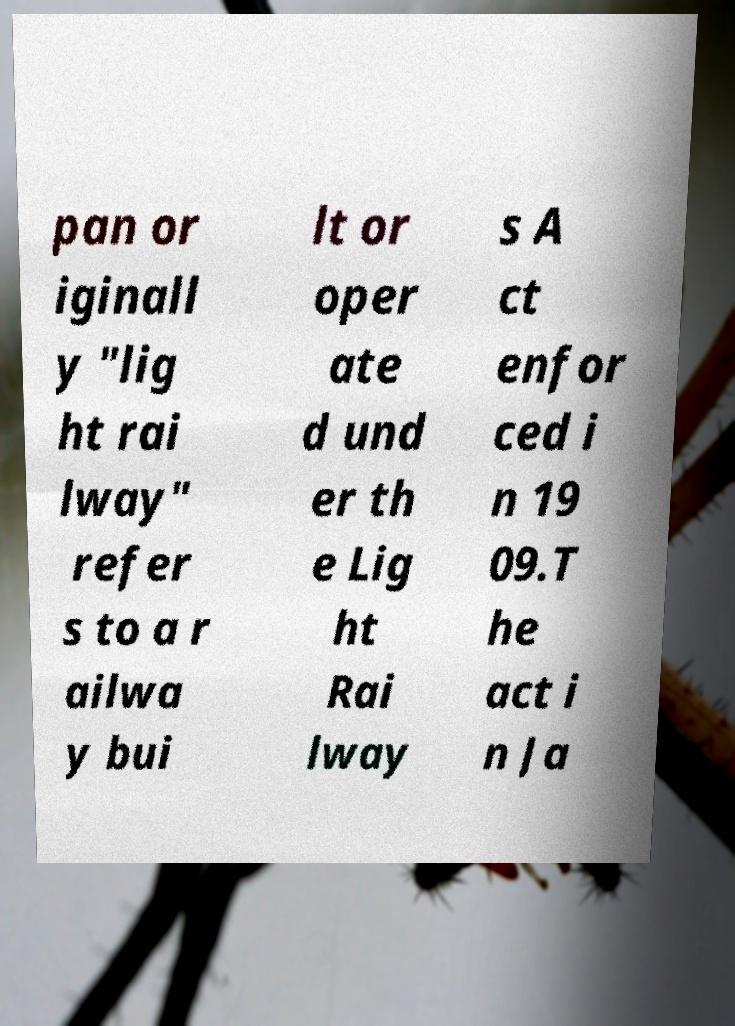Please read and relay the text visible in this image. What does it say? pan or iginall y "lig ht rai lway" refer s to a r ailwa y bui lt or oper ate d und er th e Lig ht Rai lway s A ct enfor ced i n 19 09.T he act i n Ja 